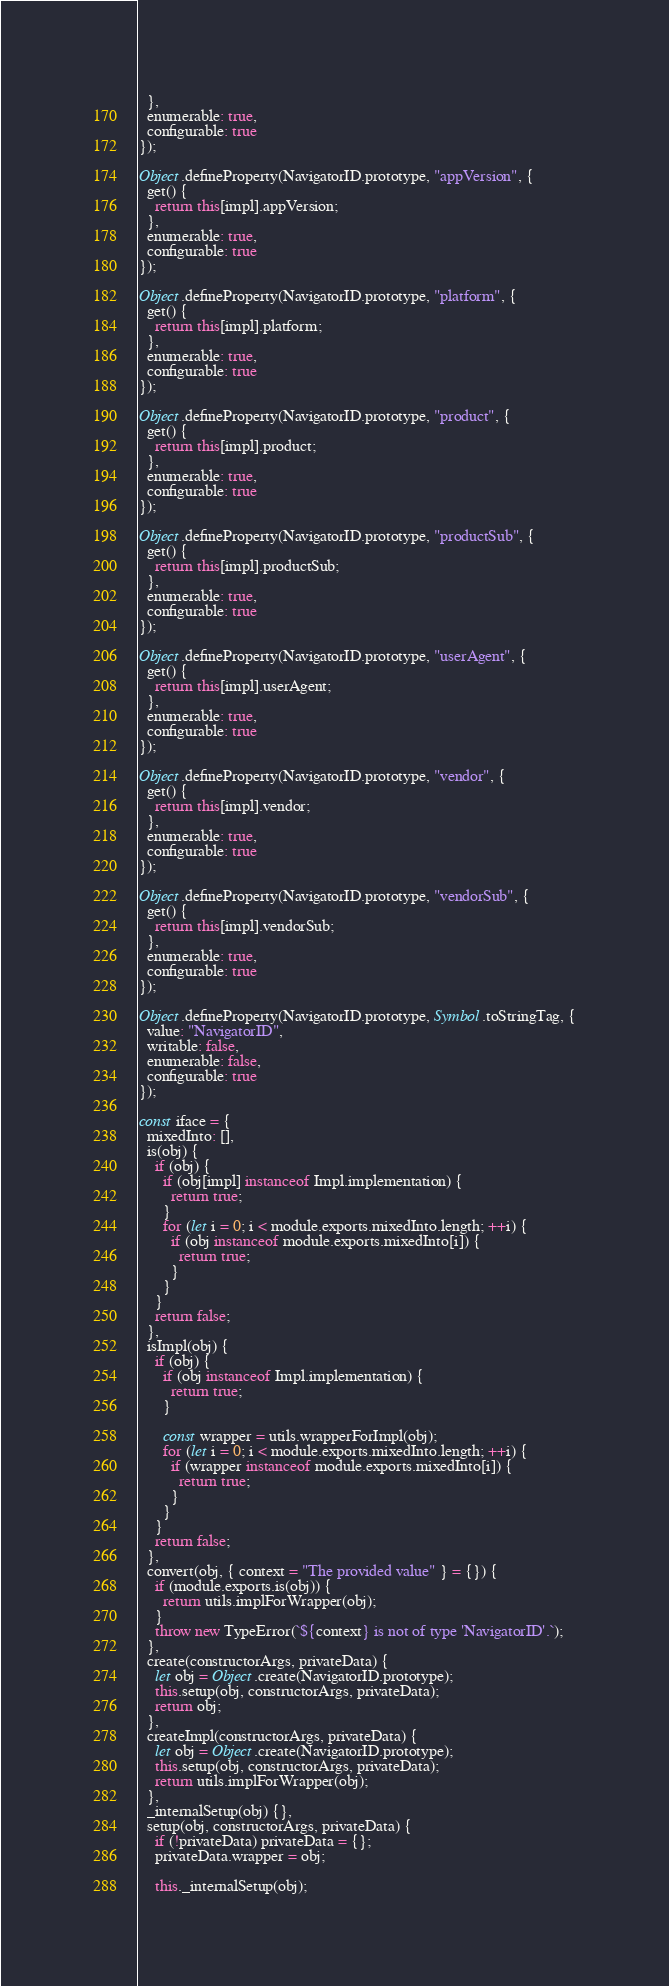<code> <loc_0><loc_0><loc_500><loc_500><_JavaScript_>  },
  enumerable: true,
  configurable: true
});

Object.defineProperty(NavigatorID.prototype, "appVersion", {
  get() {
    return this[impl].appVersion;
  },
  enumerable: true,
  configurable: true
});

Object.defineProperty(NavigatorID.prototype, "platform", {
  get() {
    return this[impl].platform;
  },
  enumerable: true,
  configurable: true
});

Object.defineProperty(NavigatorID.prototype, "product", {
  get() {
    return this[impl].product;
  },
  enumerable: true,
  configurable: true
});

Object.defineProperty(NavigatorID.prototype, "productSub", {
  get() {
    return this[impl].productSub;
  },
  enumerable: true,
  configurable: true
});

Object.defineProperty(NavigatorID.prototype, "userAgent", {
  get() {
    return this[impl].userAgent;
  },
  enumerable: true,
  configurable: true
});

Object.defineProperty(NavigatorID.prototype, "vendor", {
  get() {
    return this[impl].vendor;
  },
  enumerable: true,
  configurable: true
});

Object.defineProperty(NavigatorID.prototype, "vendorSub", {
  get() {
    return this[impl].vendorSub;
  },
  enumerable: true,
  configurable: true
});

Object.defineProperty(NavigatorID.prototype, Symbol.toStringTag, {
  value: "NavigatorID",
  writable: false,
  enumerable: false,
  configurable: true
});

const iface = {
  mixedInto: [],
  is(obj) {
    if (obj) {
      if (obj[impl] instanceof Impl.implementation) {
        return true;
      }
      for (let i = 0; i < module.exports.mixedInto.length; ++i) {
        if (obj instanceof module.exports.mixedInto[i]) {
          return true;
        }
      }
    }
    return false;
  },
  isImpl(obj) {
    if (obj) {
      if (obj instanceof Impl.implementation) {
        return true;
      }

      const wrapper = utils.wrapperForImpl(obj);
      for (let i = 0; i < module.exports.mixedInto.length; ++i) {
        if (wrapper instanceof module.exports.mixedInto[i]) {
          return true;
        }
      }
    }
    return false;
  },
  convert(obj, { context = "The provided value" } = {}) {
    if (module.exports.is(obj)) {
      return utils.implForWrapper(obj);
    }
    throw new TypeError(`${context} is not of type 'NavigatorID'.`);
  },
  create(constructorArgs, privateData) {
    let obj = Object.create(NavigatorID.prototype);
    this.setup(obj, constructorArgs, privateData);
    return obj;
  },
  createImpl(constructorArgs, privateData) {
    let obj = Object.create(NavigatorID.prototype);
    this.setup(obj, constructorArgs, privateData);
    return utils.implForWrapper(obj);
  },
  _internalSetup(obj) {},
  setup(obj, constructorArgs, privateData) {
    if (!privateData) privateData = {};
    privateData.wrapper = obj;

    this._internalSetup(obj);
</code> 